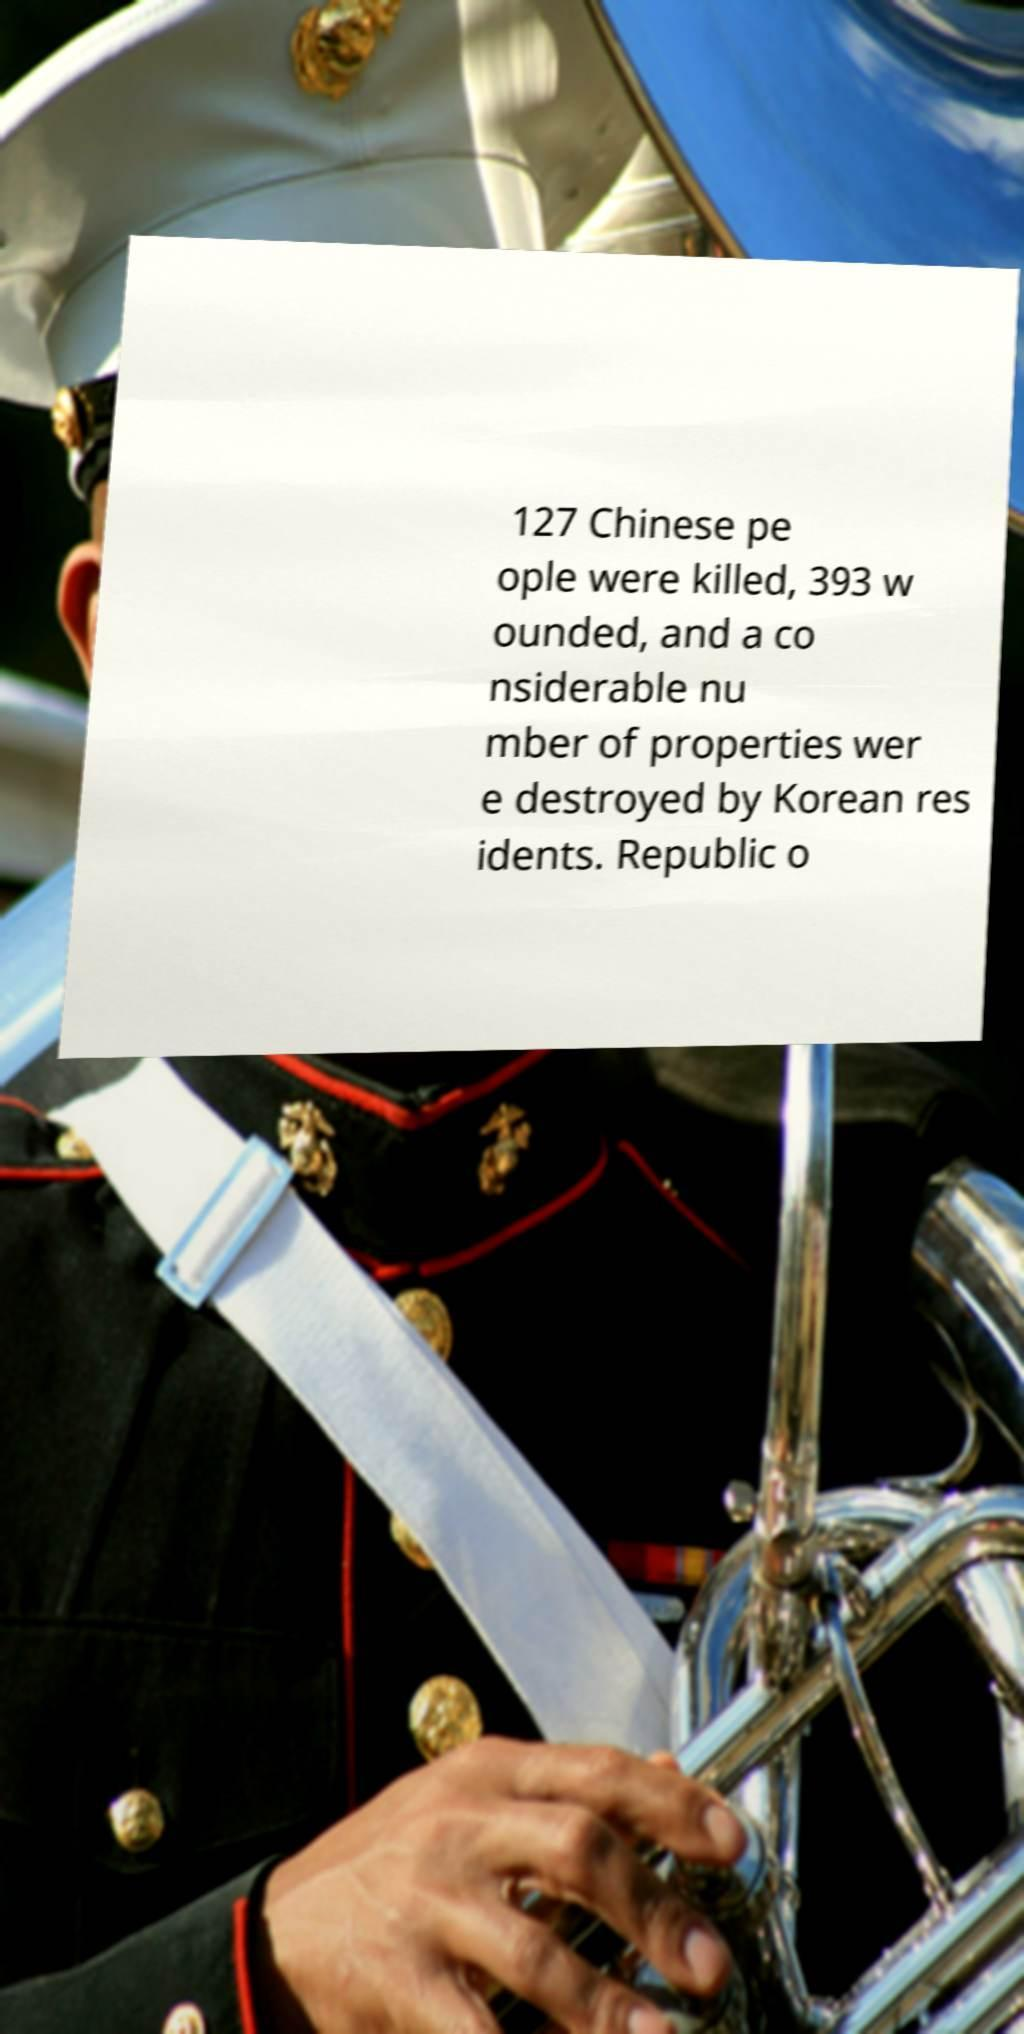Can you read and provide the text displayed in the image?This photo seems to have some interesting text. Can you extract and type it out for me? 127 Chinese pe ople were killed, 393 w ounded, and a co nsiderable nu mber of properties wer e destroyed by Korean res idents. Republic o 